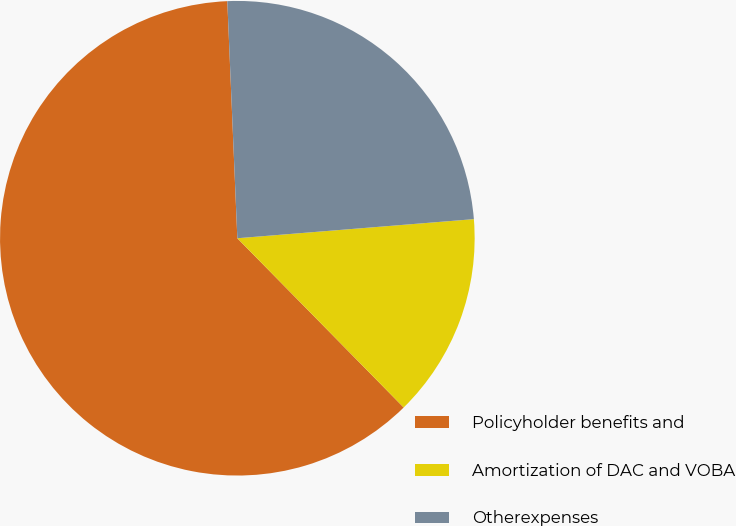Convert chart to OTSL. <chart><loc_0><loc_0><loc_500><loc_500><pie_chart><fcel>Policyholder benefits and<fcel>Amortization of DAC and VOBA<fcel>Otherexpenses<nl><fcel>61.69%<fcel>13.92%<fcel>24.39%<nl></chart> 